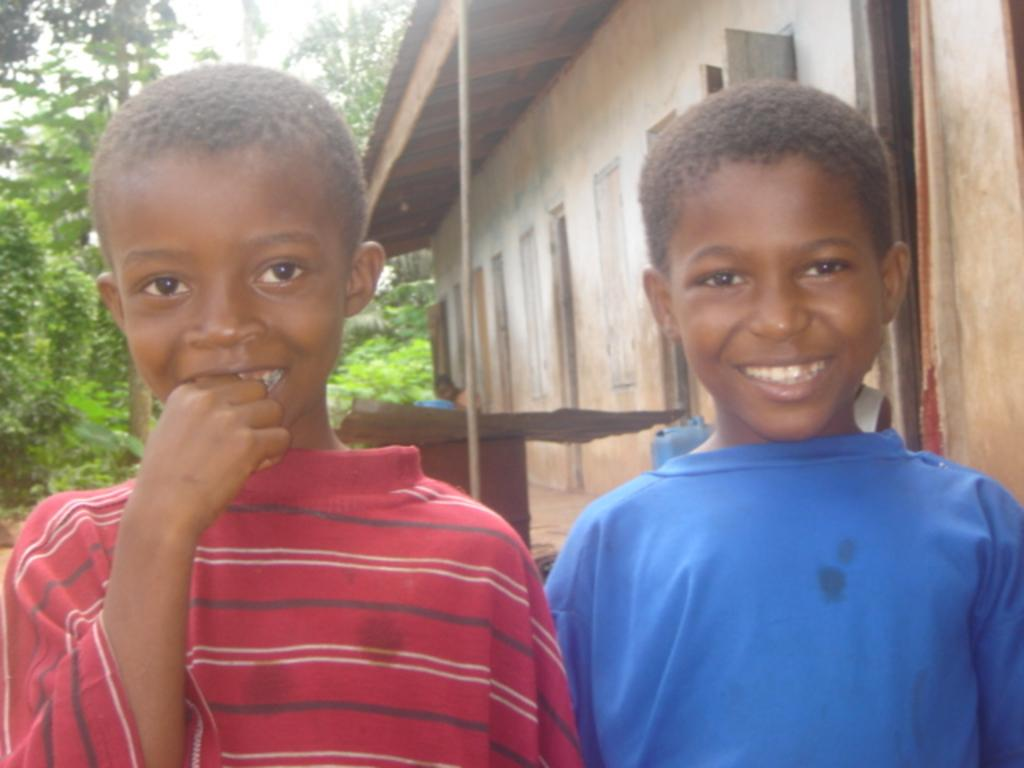What can be seen in the front of the image? There are kids in the front of the image. How are the kids in the image depicted? The kids are smiling. What is visible in the background of the image? There is a house, trees, and a pole in the background of the image. Are there any people visible in the background of the image? Yes, there is a person visible in the background of the image. What color is the patch on the icicle in the image? There is no icicle or patch present in the image. 